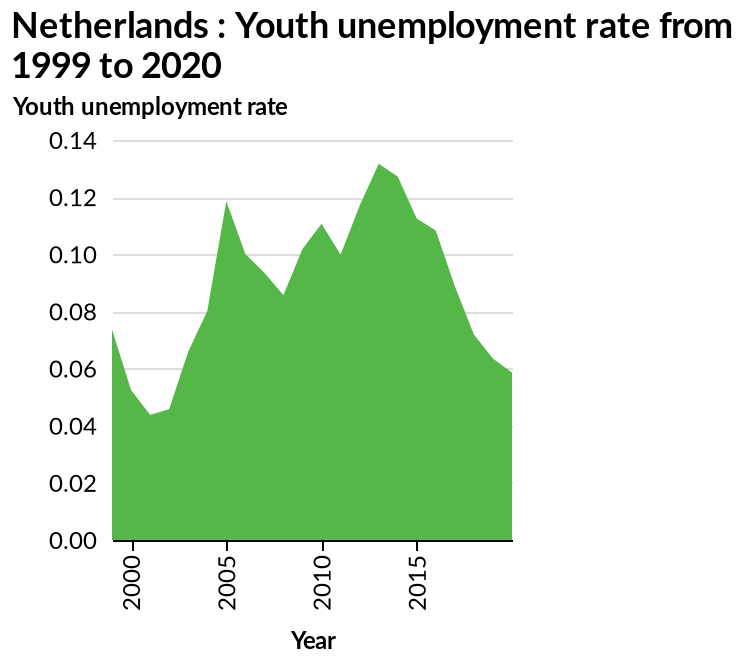<image>
What is the range of the y-axis in the area chart? The range of the y-axis in the area chart is from 0.00 to 0.14. Was there a significant change in the unemployment rate around 2015? Yes, there was a massive uptake in unemployment just before 2015. When did the massive uptake in unemployment occur?  Just before 2015. 